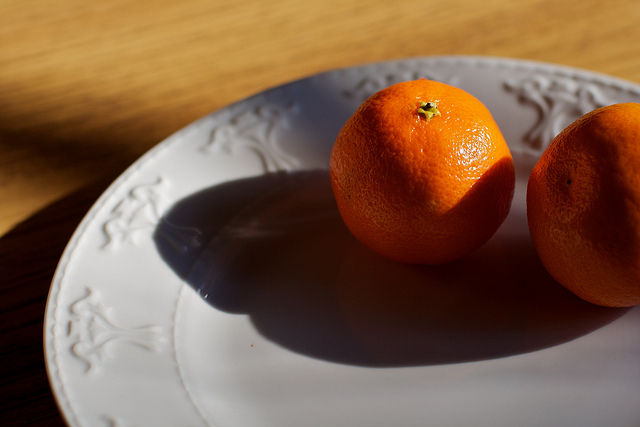What intricate details can you observe on the plate? The plate features a delicate embossed pattern running along its edge. This pattern seems inspired by nature, possibly depicting vines or leaves, adding an elegant touch to the otherwise plain white surface. The design is subtle yet sophisticated, catching the light in a way that accentuates its texture and form. 